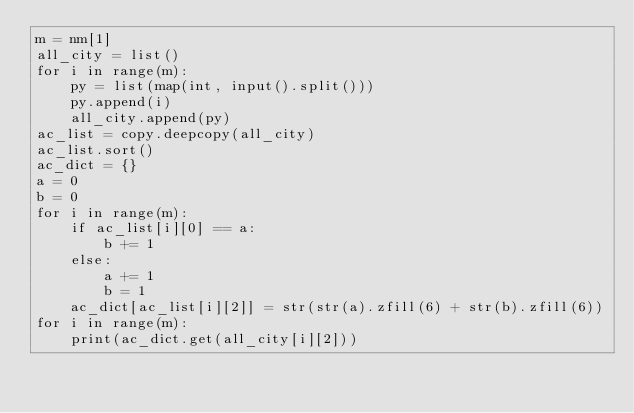Convert code to text. <code><loc_0><loc_0><loc_500><loc_500><_Python_>m = nm[1]
all_city = list()
for i in range(m):
    py = list(map(int, input().split()))
    py.append(i)
    all_city.append(py)
ac_list = copy.deepcopy(all_city)
ac_list.sort()
ac_dict = {}
a = 0
b = 0
for i in range(m):
    if ac_list[i][0] == a:
        b += 1
    else:
        a += 1
        b = 1
    ac_dict[ac_list[i][2]] = str(str(a).zfill(6) + str(b).zfill(6))
for i in range(m):
    print(ac_dict.get(all_city[i][2]))</code> 